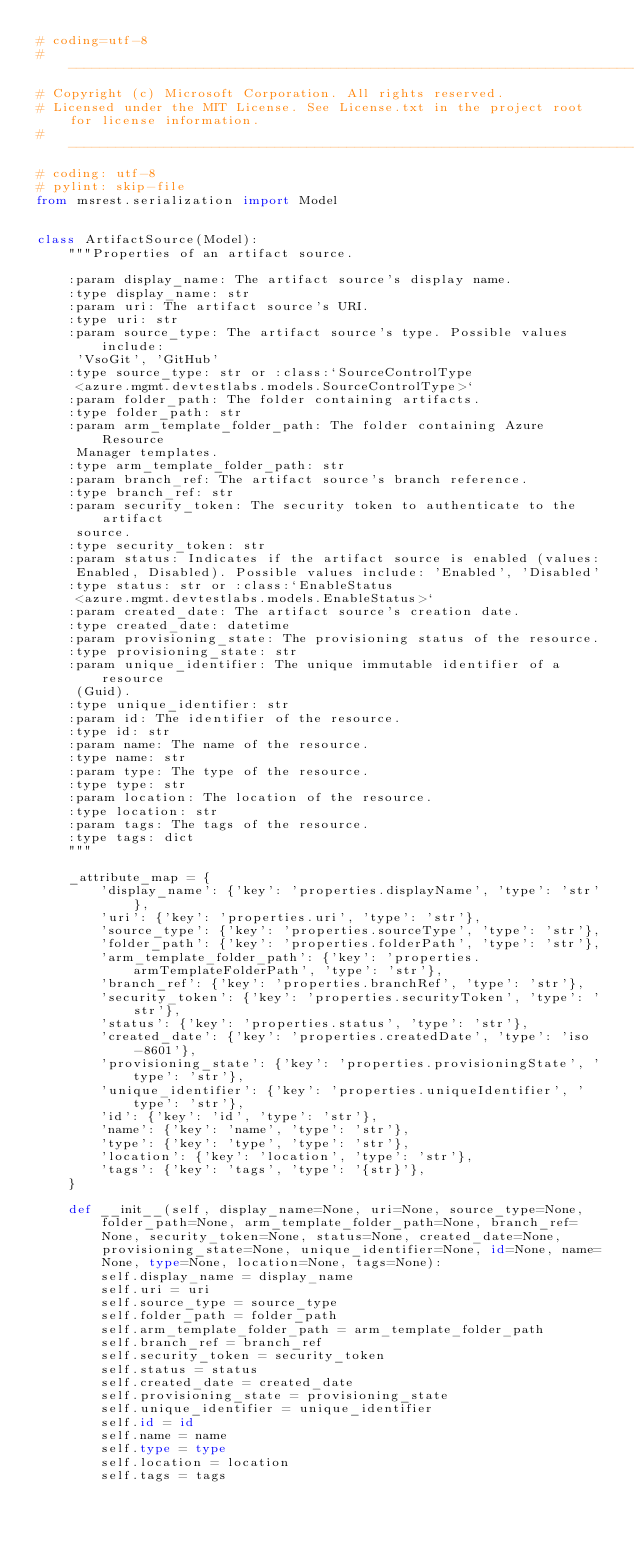Convert code to text. <code><loc_0><loc_0><loc_500><loc_500><_Python_># coding=utf-8
# --------------------------------------------------------------------------------------------
# Copyright (c) Microsoft Corporation. All rights reserved.
# Licensed under the MIT License. See License.txt in the project root for license information.
# --------------------------------------------------------------------------------------------
# coding: utf-8
# pylint: skip-file
from msrest.serialization import Model


class ArtifactSource(Model):
    """Properties of an artifact source.

    :param display_name: The artifact source's display name.
    :type display_name: str
    :param uri: The artifact source's URI.
    :type uri: str
    :param source_type: The artifact source's type. Possible values include:
     'VsoGit', 'GitHub'
    :type source_type: str or :class:`SourceControlType
     <azure.mgmt.devtestlabs.models.SourceControlType>`
    :param folder_path: The folder containing artifacts.
    :type folder_path: str
    :param arm_template_folder_path: The folder containing Azure Resource
     Manager templates.
    :type arm_template_folder_path: str
    :param branch_ref: The artifact source's branch reference.
    :type branch_ref: str
    :param security_token: The security token to authenticate to the artifact
     source.
    :type security_token: str
    :param status: Indicates if the artifact source is enabled (values:
     Enabled, Disabled). Possible values include: 'Enabled', 'Disabled'
    :type status: str or :class:`EnableStatus
     <azure.mgmt.devtestlabs.models.EnableStatus>`
    :param created_date: The artifact source's creation date.
    :type created_date: datetime
    :param provisioning_state: The provisioning status of the resource.
    :type provisioning_state: str
    :param unique_identifier: The unique immutable identifier of a resource
     (Guid).
    :type unique_identifier: str
    :param id: The identifier of the resource.
    :type id: str
    :param name: The name of the resource.
    :type name: str
    :param type: The type of the resource.
    :type type: str
    :param location: The location of the resource.
    :type location: str
    :param tags: The tags of the resource.
    :type tags: dict
    """

    _attribute_map = {
        'display_name': {'key': 'properties.displayName', 'type': 'str'},
        'uri': {'key': 'properties.uri', 'type': 'str'},
        'source_type': {'key': 'properties.sourceType', 'type': 'str'},
        'folder_path': {'key': 'properties.folderPath', 'type': 'str'},
        'arm_template_folder_path': {'key': 'properties.armTemplateFolderPath', 'type': 'str'},
        'branch_ref': {'key': 'properties.branchRef', 'type': 'str'},
        'security_token': {'key': 'properties.securityToken', 'type': 'str'},
        'status': {'key': 'properties.status', 'type': 'str'},
        'created_date': {'key': 'properties.createdDate', 'type': 'iso-8601'},
        'provisioning_state': {'key': 'properties.provisioningState', 'type': 'str'},
        'unique_identifier': {'key': 'properties.uniqueIdentifier', 'type': 'str'},
        'id': {'key': 'id', 'type': 'str'},
        'name': {'key': 'name', 'type': 'str'},
        'type': {'key': 'type', 'type': 'str'},
        'location': {'key': 'location', 'type': 'str'},
        'tags': {'key': 'tags', 'type': '{str}'},
    }

    def __init__(self, display_name=None, uri=None, source_type=None, folder_path=None, arm_template_folder_path=None, branch_ref=None, security_token=None, status=None, created_date=None, provisioning_state=None, unique_identifier=None, id=None, name=None, type=None, location=None, tags=None):
        self.display_name = display_name
        self.uri = uri
        self.source_type = source_type
        self.folder_path = folder_path
        self.arm_template_folder_path = arm_template_folder_path
        self.branch_ref = branch_ref
        self.security_token = security_token
        self.status = status
        self.created_date = created_date
        self.provisioning_state = provisioning_state
        self.unique_identifier = unique_identifier
        self.id = id
        self.name = name
        self.type = type
        self.location = location
        self.tags = tags
</code> 